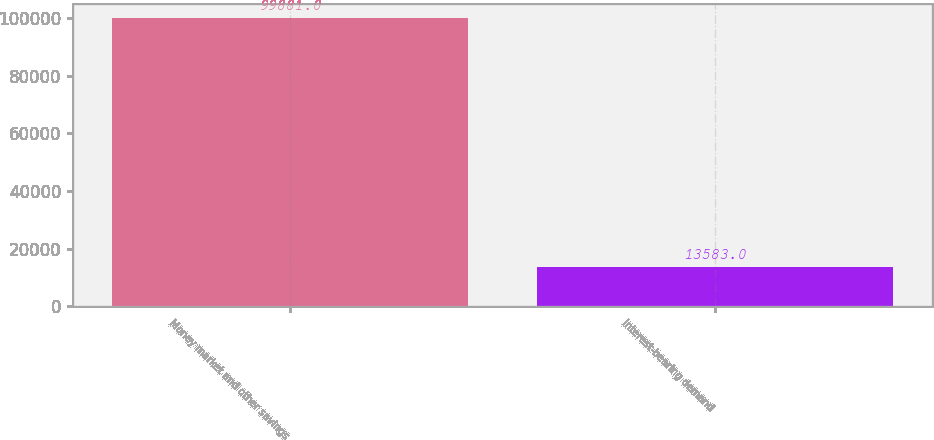Convert chart to OTSL. <chart><loc_0><loc_0><loc_500><loc_500><bar_chart><fcel>Money market and other savings<fcel>Interest-bearing demand<nl><fcel>99881<fcel>13583<nl></chart> 